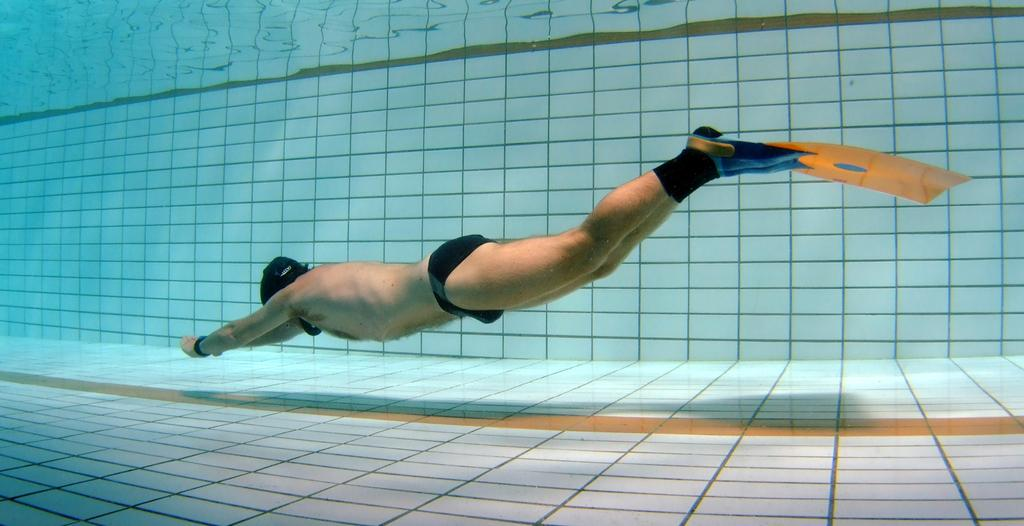What is the person in the image wearing? The person is wearing a swimming costume in the image. Where is the person located in the image? The person is in the water in the image. What type of surface can be seen beneath the water? There are tiles visible in the image. What type of oven is visible in the image? There is no oven present in the image. 